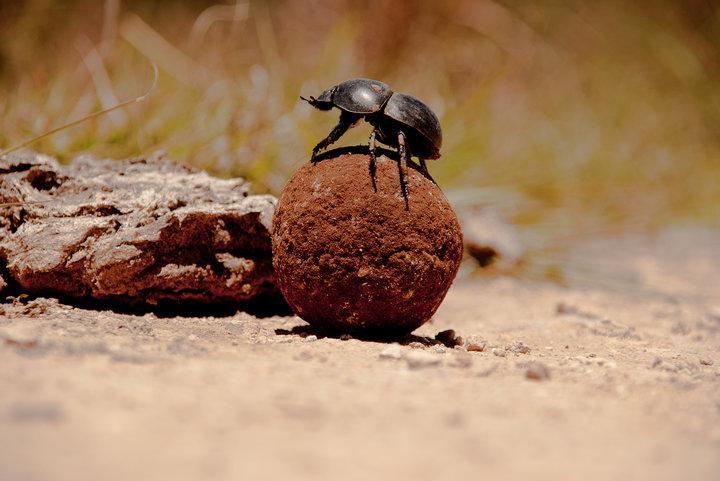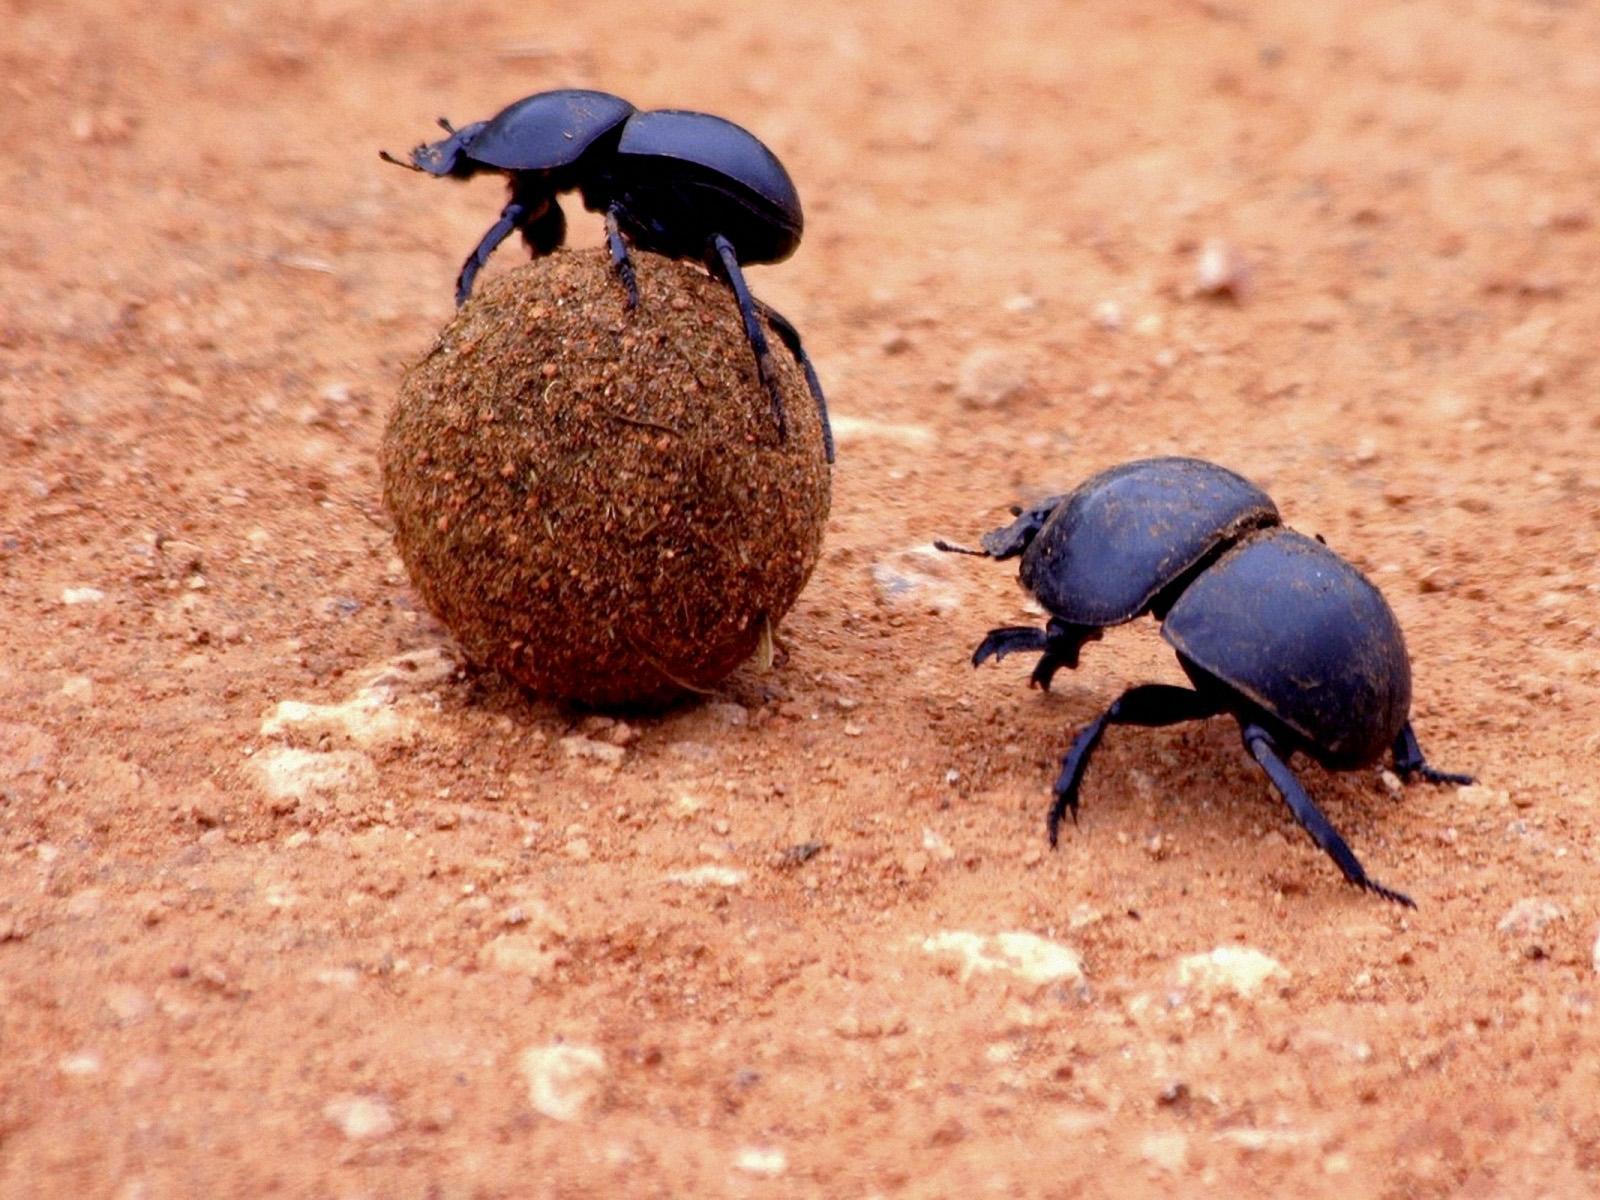The first image is the image on the left, the second image is the image on the right. Examine the images to the left and right. Is the description "There are two beetles in the right image." accurate? Answer yes or no. Yes. The first image is the image on the left, the second image is the image on the right. Examine the images to the left and right. Is the description "Each image includes at least one beetle in contact with one brown ball." accurate? Answer yes or no. Yes. 